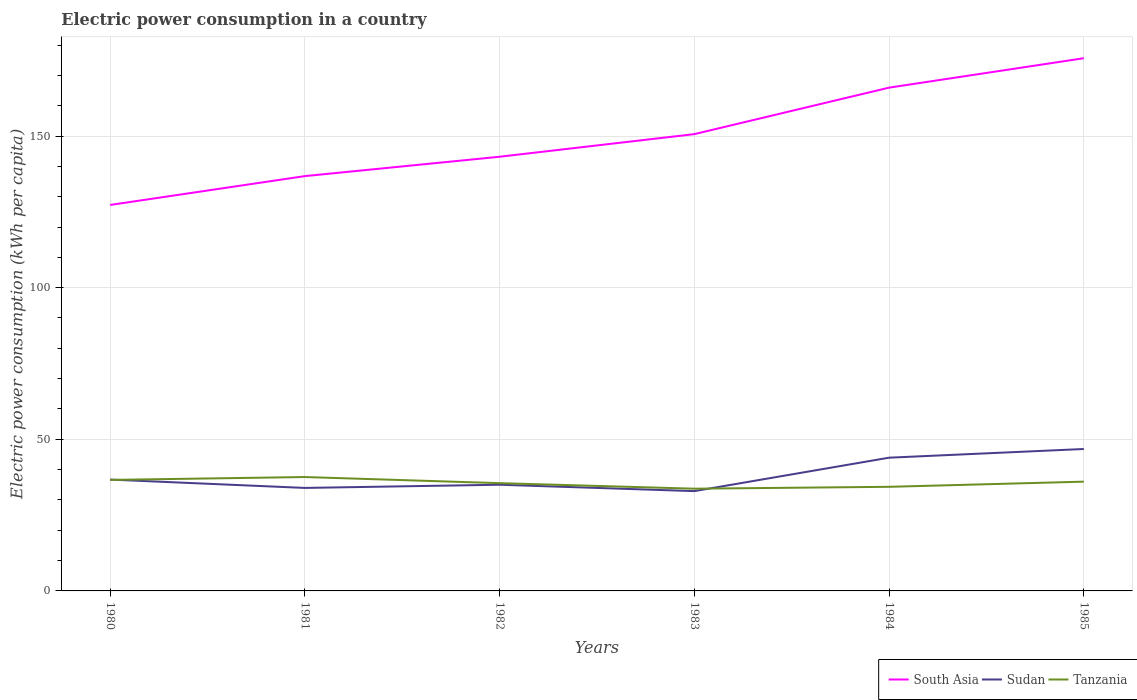How many different coloured lines are there?
Provide a short and direct response. 3. Across all years, what is the maximum electric power consumption in in Sudan?
Your response must be concise. 32.91. What is the total electric power consumption in in South Asia in the graph?
Ensure brevity in your answer.  -25.03. What is the difference between the highest and the second highest electric power consumption in in South Asia?
Ensure brevity in your answer.  48.39. What is the difference between the highest and the lowest electric power consumption in in South Asia?
Keep it short and to the point. 3. Is the electric power consumption in in Tanzania strictly greater than the electric power consumption in in South Asia over the years?
Provide a succinct answer. Yes. How many years are there in the graph?
Make the answer very short. 6. What is the difference between two consecutive major ticks on the Y-axis?
Ensure brevity in your answer.  50. Are the values on the major ticks of Y-axis written in scientific E-notation?
Your answer should be very brief. No. Does the graph contain grids?
Your answer should be very brief. Yes. How many legend labels are there?
Ensure brevity in your answer.  3. How are the legend labels stacked?
Ensure brevity in your answer.  Horizontal. What is the title of the graph?
Offer a terse response. Electric power consumption in a country. Does "Rwanda" appear as one of the legend labels in the graph?
Provide a short and direct response. No. What is the label or title of the X-axis?
Ensure brevity in your answer.  Years. What is the label or title of the Y-axis?
Ensure brevity in your answer.  Electric power consumption (kWh per capita). What is the Electric power consumption (kWh per capita) in South Asia in 1980?
Provide a succinct answer. 127.27. What is the Electric power consumption (kWh per capita) in Sudan in 1980?
Give a very brief answer. 36.72. What is the Electric power consumption (kWh per capita) in Tanzania in 1980?
Your answer should be very brief. 36.61. What is the Electric power consumption (kWh per capita) in South Asia in 1981?
Your answer should be compact. 136.78. What is the Electric power consumption (kWh per capita) of Sudan in 1981?
Make the answer very short. 33.96. What is the Electric power consumption (kWh per capita) of Tanzania in 1981?
Offer a very short reply. 37.55. What is the Electric power consumption (kWh per capita) of South Asia in 1982?
Give a very brief answer. 143.17. What is the Electric power consumption (kWh per capita) in Sudan in 1982?
Keep it short and to the point. 35.01. What is the Electric power consumption (kWh per capita) in Tanzania in 1982?
Your answer should be compact. 35.54. What is the Electric power consumption (kWh per capita) of South Asia in 1983?
Provide a short and direct response. 150.62. What is the Electric power consumption (kWh per capita) in Sudan in 1983?
Provide a short and direct response. 32.91. What is the Electric power consumption (kWh per capita) in Tanzania in 1983?
Give a very brief answer. 33.71. What is the Electric power consumption (kWh per capita) in South Asia in 1984?
Provide a short and direct response. 165.95. What is the Electric power consumption (kWh per capita) of Sudan in 1984?
Provide a succinct answer. 43.93. What is the Electric power consumption (kWh per capita) in Tanzania in 1984?
Keep it short and to the point. 34.33. What is the Electric power consumption (kWh per capita) of South Asia in 1985?
Give a very brief answer. 175.66. What is the Electric power consumption (kWh per capita) of Sudan in 1985?
Give a very brief answer. 46.8. What is the Electric power consumption (kWh per capita) of Tanzania in 1985?
Offer a terse response. 36.03. Across all years, what is the maximum Electric power consumption (kWh per capita) in South Asia?
Your response must be concise. 175.66. Across all years, what is the maximum Electric power consumption (kWh per capita) of Sudan?
Offer a very short reply. 46.8. Across all years, what is the maximum Electric power consumption (kWh per capita) of Tanzania?
Offer a terse response. 37.55. Across all years, what is the minimum Electric power consumption (kWh per capita) of South Asia?
Offer a terse response. 127.27. Across all years, what is the minimum Electric power consumption (kWh per capita) in Sudan?
Your answer should be compact. 32.91. Across all years, what is the minimum Electric power consumption (kWh per capita) of Tanzania?
Offer a terse response. 33.71. What is the total Electric power consumption (kWh per capita) of South Asia in the graph?
Give a very brief answer. 899.45. What is the total Electric power consumption (kWh per capita) in Sudan in the graph?
Give a very brief answer. 229.34. What is the total Electric power consumption (kWh per capita) in Tanzania in the graph?
Your answer should be compact. 213.77. What is the difference between the Electric power consumption (kWh per capita) of South Asia in 1980 and that in 1981?
Offer a terse response. -9.51. What is the difference between the Electric power consumption (kWh per capita) of Sudan in 1980 and that in 1981?
Provide a short and direct response. 2.75. What is the difference between the Electric power consumption (kWh per capita) in Tanzania in 1980 and that in 1981?
Offer a very short reply. -0.95. What is the difference between the Electric power consumption (kWh per capita) in South Asia in 1980 and that in 1982?
Your answer should be compact. -15.9. What is the difference between the Electric power consumption (kWh per capita) of Sudan in 1980 and that in 1982?
Offer a terse response. 1.7. What is the difference between the Electric power consumption (kWh per capita) in Tanzania in 1980 and that in 1982?
Offer a terse response. 1.07. What is the difference between the Electric power consumption (kWh per capita) in South Asia in 1980 and that in 1983?
Offer a terse response. -23.35. What is the difference between the Electric power consumption (kWh per capita) in Sudan in 1980 and that in 1983?
Keep it short and to the point. 3.81. What is the difference between the Electric power consumption (kWh per capita) of Tanzania in 1980 and that in 1983?
Keep it short and to the point. 2.9. What is the difference between the Electric power consumption (kWh per capita) in South Asia in 1980 and that in 1984?
Your response must be concise. -38.69. What is the difference between the Electric power consumption (kWh per capita) in Sudan in 1980 and that in 1984?
Your answer should be compact. -7.22. What is the difference between the Electric power consumption (kWh per capita) in Tanzania in 1980 and that in 1984?
Your answer should be compact. 2.28. What is the difference between the Electric power consumption (kWh per capita) in South Asia in 1980 and that in 1985?
Ensure brevity in your answer.  -48.39. What is the difference between the Electric power consumption (kWh per capita) of Sudan in 1980 and that in 1985?
Make the answer very short. -10.08. What is the difference between the Electric power consumption (kWh per capita) in Tanzania in 1980 and that in 1985?
Give a very brief answer. 0.58. What is the difference between the Electric power consumption (kWh per capita) in South Asia in 1981 and that in 1982?
Offer a very short reply. -6.39. What is the difference between the Electric power consumption (kWh per capita) in Sudan in 1981 and that in 1982?
Provide a short and direct response. -1.05. What is the difference between the Electric power consumption (kWh per capita) in Tanzania in 1981 and that in 1982?
Offer a terse response. 2.02. What is the difference between the Electric power consumption (kWh per capita) of South Asia in 1981 and that in 1983?
Make the answer very short. -13.84. What is the difference between the Electric power consumption (kWh per capita) of Sudan in 1981 and that in 1983?
Your response must be concise. 1.06. What is the difference between the Electric power consumption (kWh per capita) in Tanzania in 1981 and that in 1983?
Provide a succinct answer. 3.84. What is the difference between the Electric power consumption (kWh per capita) of South Asia in 1981 and that in 1984?
Offer a very short reply. -29.17. What is the difference between the Electric power consumption (kWh per capita) in Sudan in 1981 and that in 1984?
Your response must be concise. -9.97. What is the difference between the Electric power consumption (kWh per capita) in Tanzania in 1981 and that in 1984?
Your response must be concise. 3.22. What is the difference between the Electric power consumption (kWh per capita) in South Asia in 1981 and that in 1985?
Provide a short and direct response. -38.87. What is the difference between the Electric power consumption (kWh per capita) of Sudan in 1981 and that in 1985?
Give a very brief answer. -12.84. What is the difference between the Electric power consumption (kWh per capita) in Tanzania in 1981 and that in 1985?
Provide a succinct answer. 1.52. What is the difference between the Electric power consumption (kWh per capita) of South Asia in 1982 and that in 1983?
Offer a very short reply. -7.46. What is the difference between the Electric power consumption (kWh per capita) in Sudan in 1982 and that in 1983?
Provide a succinct answer. 2.11. What is the difference between the Electric power consumption (kWh per capita) in Tanzania in 1982 and that in 1983?
Keep it short and to the point. 1.83. What is the difference between the Electric power consumption (kWh per capita) of South Asia in 1982 and that in 1984?
Your answer should be very brief. -22.79. What is the difference between the Electric power consumption (kWh per capita) of Sudan in 1982 and that in 1984?
Your answer should be very brief. -8.92. What is the difference between the Electric power consumption (kWh per capita) in Tanzania in 1982 and that in 1984?
Your answer should be very brief. 1.21. What is the difference between the Electric power consumption (kWh per capita) of South Asia in 1982 and that in 1985?
Ensure brevity in your answer.  -32.49. What is the difference between the Electric power consumption (kWh per capita) in Sudan in 1982 and that in 1985?
Make the answer very short. -11.79. What is the difference between the Electric power consumption (kWh per capita) of Tanzania in 1982 and that in 1985?
Provide a short and direct response. -0.49. What is the difference between the Electric power consumption (kWh per capita) of South Asia in 1983 and that in 1984?
Provide a succinct answer. -15.33. What is the difference between the Electric power consumption (kWh per capita) in Sudan in 1983 and that in 1984?
Your answer should be very brief. -11.03. What is the difference between the Electric power consumption (kWh per capita) of Tanzania in 1983 and that in 1984?
Keep it short and to the point. -0.62. What is the difference between the Electric power consumption (kWh per capita) of South Asia in 1983 and that in 1985?
Offer a terse response. -25.03. What is the difference between the Electric power consumption (kWh per capita) of Sudan in 1983 and that in 1985?
Keep it short and to the point. -13.89. What is the difference between the Electric power consumption (kWh per capita) in Tanzania in 1983 and that in 1985?
Your answer should be compact. -2.32. What is the difference between the Electric power consumption (kWh per capita) in South Asia in 1984 and that in 1985?
Your response must be concise. -9.7. What is the difference between the Electric power consumption (kWh per capita) in Sudan in 1984 and that in 1985?
Provide a short and direct response. -2.87. What is the difference between the Electric power consumption (kWh per capita) of Tanzania in 1984 and that in 1985?
Give a very brief answer. -1.7. What is the difference between the Electric power consumption (kWh per capita) in South Asia in 1980 and the Electric power consumption (kWh per capita) in Sudan in 1981?
Ensure brevity in your answer.  93.3. What is the difference between the Electric power consumption (kWh per capita) in South Asia in 1980 and the Electric power consumption (kWh per capita) in Tanzania in 1981?
Give a very brief answer. 89.72. What is the difference between the Electric power consumption (kWh per capita) in Sudan in 1980 and the Electric power consumption (kWh per capita) in Tanzania in 1981?
Offer a very short reply. -0.84. What is the difference between the Electric power consumption (kWh per capita) in South Asia in 1980 and the Electric power consumption (kWh per capita) in Sudan in 1982?
Provide a succinct answer. 92.26. What is the difference between the Electric power consumption (kWh per capita) in South Asia in 1980 and the Electric power consumption (kWh per capita) in Tanzania in 1982?
Your response must be concise. 91.73. What is the difference between the Electric power consumption (kWh per capita) of Sudan in 1980 and the Electric power consumption (kWh per capita) of Tanzania in 1982?
Ensure brevity in your answer.  1.18. What is the difference between the Electric power consumption (kWh per capita) of South Asia in 1980 and the Electric power consumption (kWh per capita) of Sudan in 1983?
Offer a very short reply. 94.36. What is the difference between the Electric power consumption (kWh per capita) in South Asia in 1980 and the Electric power consumption (kWh per capita) in Tanzania in 1983?
Your answer should be compact. 93.56. What is the difference between the Electric power consumption (kWh per capita) in Sudan in 1980 and the Electric power consumption (kWh per capita) in Tanzania in 1983?
Your answer should be very brief. 3.01. What is the difference between the Electric power consumption (kWh per capita) of South Asia in 1980 and the Electric power consumption (kWh per capita) of Sudan in 1984?
Your response must be concise. 83.33. What is the difference between the Electric power consumption (kWh per capita) of South Asia in 1980 and the Electric power consumption (kWh per capita) of Tanzania in 1984?
Provide a short and direct response. 92.94. What is the difference between the Electric power consumption (kWh per capita) in Sudan in 1980 and the Electric power consumption (kWh per capita) in Tanzania in 1984?
Offer a terse response. 2.39. What is the difference between the Electric power consumption (kWh per capita) in South Asia in 1980 and the Electric power consumption (kWh per capita) in Sudan in 1985?
Ensure brevity in your answer.  80.47. What is the difference between the Electric power consumption (kWh per capita) of South Asia in 1980 and the Electric power consumption (kWh per capita) of Tanzania in 1985?
Ensure brevity in your answer.  91.24. What is the difference between the Electric power consumption (kWh per capita) of Sudan in 1980 and the Electric power consumption (kWh per capita) of Tanzania in 1985?
Ensure brevity in your answer.  0.69. What is the difference between the Electric power consumption (kWh per capita) in South Asia in 1981 and the Electric power consumption (kWh per capita) in Sudan in 1982?
Provide a succinct answer. 101.77. What is the difference between the Electric power consumption (kWh per capita) of South Asia in 1981 and the Electric power consumption (kWh per capita) of Tanzania in 1982?
Ensure brevity in your answer.  101.25. What is the difference between the Electric power consumption (kWh per capita) in Sudan in 1981 and the Electric power consumption (kWh per capita) in Tanzania in 1982?
Keep it short and to the point. -1.57. What is the difference between the Electric power consumption (kWh per capita) of South Asia in 1981 and the Electric power consumption (kWh per capita) of Sudan in 1983?
Your answer should be compact. 103.88. What is the difference between the Electric power consumption (kWh per capita) of South Asia in 1981 and the Electric power consumption (kWh per capita) of Tanzania in 1983?
Offer a terse response. 103.07. What is the difference between the Electric power consumption (kWh per capita) in Sudan in 1981 and the Electric power consumption (kWh per capita) in Tanzania in 1983?
Give a very brief answer. 0.26. What is the difference between the Electric power consumption (kWh per capita) in South Asia in 1981 and the Electric power consumption (kWh per capita) in Sudan in 1984?
Provide a short and direct response. 92.85. What is the difference between the Electric power consumption (kWh per capita) of South Asia in 1981 and the Electric power consumption (kWh per capita) of Tanzania in 1984?
Provide a succinct answer. 102.45. What is the difference between the Electric power consumption (kWh per capita) in Sudan in 1981 and the Electric power consumption (kWh per capita) in Tanzania in 1984?
Provide a succinct answer. -0.36. What is the difference between the Electric power consumption (kWh per capita) in South Asia in 1981 and the Electric power consumption (kWh per capita) in Sudan in 1985?
Your response must be concise. 89.98. What is the difference between the Electric power consumption (kWh per capita) of South Asia in 1981 and the Electric power consumption (kWh per capita) of Tanzania in 1985?
Give a very brief answer. 100.75. What is the difference between the Electric power consumption (kWh per capita) of Sudan in 1981 and the Electric power consumption (kWh per capita) of Tanzania in 1985?
Your answer should be very brief. -2.07. What is the difference between the Electric power consumption (kWh per capita) in South Asia in 1982 and the Electric power consumption (kWh per capita) in Sudan in 1983?
Your answer should be compact. 110.26. What is the difference between the Electric power consumption (kWh per capita) in South Asia in 1982 and the Electric power consumption (kWh per capita) in Tanzania in 1983?
Your response must be concise. 109.46. What is the difference between the Electric power consumption (kWh per capita) of Sudan in 1982 and the Electric power consumption (kWh per capita) of Tanzania in 1983?
Provide a short and direct response. 1.3. What is the difference between the Electric power consumption (kWh per capita) of South Asia in 1982 and the Electric power consumption (kWh per capita) of Sudan in 1984?
Ensure brevity in your answer.  99.23. What is the difference between the Electric power consumption (kWh per capita) in South Asia in 1982 and the Electric power consumption (kWh per capita) in Tanzania in 1984?
Provide a short and direct response. 108.84. What is the difference between the Electric power consumption (kWh per capita) in Sudan in 1982 and the Electric power consumption (kWh per capita) in Tanzania in 1984?
Provide a succinct answer. 0.69. What is the difference between the Electric power consumption (kWh per capita) in South Asia in 1982 and the Electric power consumption (kWh per capita) in Sudan in 1985?
Your answer should be compact. 96.37. What is the difference between the Electric power consumption (kWh per capita) in South Asia in 1982 and the Electric power consumption (kWh per capita) in Tanzania in 1985?
Your answer should be compact. 107.14. What is the difference between the Electric power consumption (kWh per capita) of Sudan in 1982 and the Electric power consumption (kWh per capita) of Tanzania in 1985?
Give a very brief answer. -1.02. What is the difference between the Electric power consumption (kWh per capita) of South Asia in 1983 and the Electric power consumption (kWh per capita) of Sudan in 1984?
Make the answer very short. 106.69. What is the difference between the Electric power consumption (kWh per capita) of South Asia in 1983 and the Electric power consumption (kWh per capita) of Tanzania in 1984?
Offer a terse response. 116.3. What is the difference between the Electric power consumption (kWh per capita) of Sudan in 1983 and the Electric power consumption (kWh per capita) of Tanzania in 1984?
Your answer should be very brief. -1.42. What is the difference between the Electric power consumption (kWh per capita) of South Asia in 1983 and the Electric power consumption (kWh per capita) of Sudan in 1985?
Make the answer very short. 103.82. What is the difference between the Electric power consumption (kWh per capita) of South Asia in 1983 and the Electric power consumption (kWh per capita) of Tanzania in 1985?
Your response must be concise. 114.59. What is the difference between the Electric power consumption (kWh per capita) of Sudan in 1983 and the Electric power consumption (kWh per capita) of Tanzania in 1985?
Your response must be concise. -3.12. What is the difference between the Electric power consumption (kWh per capita) in South Asia in 1984 and the Electric power consumption (kWh per capita) in Sudan in 1985?
Provide a short and direct response. 119.15. What is the difference between the Electric power consumption (kWh per capita) of South Asia in 1984 and the Electric power consumption (kWh per capita) of Tanzania in 1985?
Ensure brevity in your answer.  129.92. What is the difference between the Electric power consumption (kWh per capita) in Sudan in 1984 and the Electric power consumption (kWh per capita) in Tanzania in 1985?
Provide a succinct answer. 7.9. What is the average Electric power consumption (kWh per capita) in South Asia per year?
Ensure brevity in your answer.  149.91. What is the average Electric power consumption (kWh per capita) of Sudan per year?
Ensure brevity in your answer.  38.22. What is the average Electric power consumption (kWh per capita) of Tanzania per year?
Give a very brief answer. 35.63. In the year 1980, what is the difference between the Electric power consumption (kWh per capita) of South Asia and Electric power consumption (kWh per capita) of Sudan?
Keep it short and to the point. 90.55. In the year 1980, what is the difference between the Electric power consumption (kWh per capita) of South Asia and Electric power consumption (kWh per capita) of Tanzania?
Your answer should be compact. 90.66. In the year 1980, what is the difference between the Electric power consumption (kWh per capita) in Sudan and Electric power consumption (kWh per capita) in Tanzania?
Provide a succinct answer. 0.11. In the year 1981, what is the difference between the Electric power consumption (kWh per capita) of South Asia and Electric power consumption (kWh per capita) of Sudan?
Offer a very short reply. 102.82. In the year 1981, what is the difference between the Electric power consumption (kWh per capita) of South Asia and Electric power consumption (kWh per capita) of Tanzania?
Give a very brief answer. 99.23. In the year 1981, what is the difference between the Electric power consumption (kWh per capita) in Sudan and Electric power consumption (kWh per capita) in Tanzania?
Your response must be concise. -3.59. In the year 1982, what is the difference between the Electric power consumption (kWh per capita) in South Asia and Electric power consumption (kWh per capita) in Sudan?
Provide a short and direct response. 108.15. In the year 1982, what is the difference between the Electric power consumption (kWh per capita) of South Asia and Electric power consumption (kWh per capita) of Tanzania?
Your response must be concise. 107.63. In the year 1982, what is the difference between the Electric power consumption (kWh per capita) in Sudan and Electric power consumption (kWh per capita) in Tanzania?
Ensure brevity in your answer.  -0.52. In the year 1983, what is the difference between the Electric power consumption (kWh per capita) in South Asia and Electric power consumption (kWh per capita) in Sudan?
Offer a very short reply. 117.72. In the year 1983, what is the difference between the Electric power consumption (kWh per capita) of South Asia and Electric power consumption (kWh per capita) of Tanzania?
Keep it short and to the point. 116.91. In the year 1983, what is the difference between the Electric power consumption (kWh per capita) of Sudan and Electric power consumption (kWh per capita) of Tanzania?
Make the answer very short. -0.8. In the year 1984, what is the difference between the Electric power consumption (kWh per capita) in South Asia and Electric power consumption (kWh per capita) in Sudan?
Give a very brief answer. 122.02. In the year 1984, what is the difference between the Electric power consumption (kWh per capita) in South Asia and Electric power consumption (kWh per capita) in Tanzania?
Your answer should be very brief. 131.63. In the year 1984, what is the difference between the Electric power consumption (kWh per capita) in Sudan and Electric power consumption (kWh per capita) in Tanzania?
Your answer should be very brief. 9.61. In the year 1985, what is the difference between the Electric power consumption (kWh per capita) of South Asia and Electric power consumption (kWh per capita) of Sudan?
Ensure brevity in your answer.  128.86. In the year 1985, what is the difference between the Electric power consumption (kWh per capita) of South Asia and Electric power consumption (kWh per capita) of Tanzania?
Offer a very short reply. 139.62. In the year 1985, what is the difference between the Electric power consumption (kWh per capita) of Sudan and Electric power consumption (kWh per capita) of Tanzania?
Offer a terse response. 10.77. What is the ratio of the Electric power consumption (kWh per capita) of South Asia in 1980 to that in 1981?
Provide a succinct answer. 0.93. What is the ratio of the Electric power consumption (kWh per capita) in Sudan in 1980 to that in 1981?
Give a very brief answer. 1.08. What is the ratio of the Electric power consumption (kWh per capita) in Tanzania in 1980 to that in 1981?
Give a very brief answer. 0.97. What is the ratio of the Electric power consumption (kWh per capita) in South Asia in 1980 to that in 1982?
Offer a terse response. 0.89. What is the ratio of the Electric power consumption (kWh per capita) in Sudan in 1980 to that in 1982?
Offer a terse response. 1.05. What is the ratio of the Electric power consumption (kWh per capita) of Tanzania in 1980 to that in 1982?
Your answer should be very brief. 1.03. What is the ratio of the Electric power consumption (kWh per capita) in South Asia in 1980 to that in 1983?
Keep it short and to the point. 0.84. What is the ratio of the Electric power consumption (kWh per capita) in Sudan in 1980 to that in 1983?
Provide a short and direct response. 1.12. What is the ratio of the Electric power consumption (kWh per capita) of Tanzania in 1980 to that in 1983?
Provide a short and direct response. 1.09. What is the ratio of the Electric power consumption (kWh per capita) in South Asia in 1980 to that in 1984?
Your response must be concise. 0.77. What is the ratio of the Electric power consumption (kWh per capita) of Sudan in 1980 to that in 1984?
Make the answer very short. 0.84. What is the ratio of the Electric power consumption (kWh per capita) in Tanzania in 1980 to that in 1984?
Provide a succinct answer. 1.07. What is the ratio of the Electric power consumption (kWh per capita) of South Asia in 1980 to that in 1985?
Ensure brevity in your answer.  0.72. What is the ratio of the Electric power consumption (kWh per capita) in Sudan in 1980 to that in 1985?
Your answer should be very brief. 0.78. What is the ratio of the Electric power consumption (kWh per capita) of Tanzania in 1980 to that in 1985?
Your answer should be compact. 1.02. What is the ratio of the Electric power consumption (kWh per capita) in South Asia in 1981 to that in 1982?
Provide a short and direct response. 0.96. What is the ratio of the Electric power consumption (kWh per capita) of Tanzania in 1981 to that in 1982?
Keep it short and to the point. 1.06. What is the ratio of the Electric power consumption (kWh per capita) of South Asia in 1981 to that in 1983?
Keep it short and to the point. 0.91. What is the ratio of the Electric power consumption (kWh per capita) in Sudan in 1981 to that in 1983?
Provide a succinct answer. 1.03. What is the ratio of the Electric power consumption (kWh per capita) of Tanzania in 1981 to that in 1983?
Offer a very short reply. 1.11. What is the ratio of the Electric power consumption (kWh per capita) of South Asia in 1981 to that in 1984?
Keep it short and to the point. 0.82. What is the ratio of the Electric power consumption (kWh per capita) of Sudan in 1981 to that in 1984?
Offer a very short reply. 0.77. What is the ratio of the Electric power consumption (kWh per capita) of Tanzania in 1981 to that in 1984?
Ensure brevity in your answer.  1.09. What is the ratio of the Electric power consumption (kWh per capita) in South Asia in 1981 to that in 1985?
Provide a short and direct response. 0.78. What is the ratio of the Electric power consumption (kWh per capita) of Sudan in 1981 to that in 1985?
Offer a terse response. 0.73. What is the ratio of the Electric power consumption (kWh per capita) in Tanzania in 1981 to that in 1985?
Keep it short and to the point. 1.04. What is the ratio of the Electric power consumption (kWh per capita) in South Asia in 1982 to that in 1983?
Provide a short and direct response. 0.95. What is the ratio of the Electric power consumption (kWh per capita) in Sudan in 1982 to that in 1983?
Your answer should be compact. 1.06. What is the ratio of the Electric power consumption (kWh per capita) of Tanzania in 1982 to that in 1983?
Make the answer very short. 1.05. What is the ratio of the Electric power consumption (kWh per capita) in South Asia in 1982 to that in 1984?
Provide a succinct answer. 0.86. What is the ratio of the Electric power consumption (kWh per capita) in Sudan in 1982 to that in 1984?
Give a very brief answer. 0.8. What is the ratio of the Electric power consumption (kWh per capita) in Tanzania in 1982 to that in 1984?
Offer a terse response. 1.04. What is the ratio of the Electric power consumption (kWh per capita) in South Asia in 1982 to that in 1985?
Offer a terse response. 0.81. What is the ratio of the Electric power consumption (kWh per capita) of Sudan in 1982 to that in 1985?
Provide a short and direct response. 0.75. What is the ratio of the Electric power consumption (kWh per capita) of Tanzania in 1982 to that in 1985?
Your response must be concise. 0.99. What is the ratio of the Electric power consumption (kWh per capita) of South Asia in 1983 to that in 1984?
Your response must be concise. 0.91. What is the ratio of the Electric power consumption (kWh per capita) of Sudan in 1983 to that in 1984?
Ensure brevity in your answer.  0.75. What is the ratio of the Electric power consumption (kWh per capita) in South Asia in 1983 to that in 1985?
Make the answer very short. 0.86. What is the ratio of the Electric power consumption (kWh per capita) in Sudan in 1983 to that in 1985?
Offer a very short reply. 0.7. What is the ratio of the Electric power consumption (kWh per capita) of Tanzania in 1983 to that in 1985?
Your answer should be very brief. 0.94. What is the ratio of the Electric power consumption (kWh per capita) in South Asia in 1984 to that in 1985?
Make the answer very short. 0.94. What is the ratio of the Electric power consumption (kWh per capita) in Sudan in 1984 to that in 1985?
Make the answer very short. 0.94. What is the ratio of the Electric power consumption (kWh per capita) in Tanzania in 1984 to that in 1985?
Keep it short and to the point. 0.95. What is the difference between the highest and the second highest Electric power consumption (kWh per capita) in South Asia?
Ensure brevity in your answer.  9.7. What is the difference between the highest and the second highest Electric power consumption (kWh per capita) of Sudan?
Ensure brevity in your answer.  2.87. What is the difference between the highest and the second highest Electric power consumption (kWh per capita) in Tanzania?
Ensure brevity in your answer.  0.95. What is the difference between the highest and the lowest Electric power consumption (kWh per capita) of South Asia?
Keep it short and to the point. 48.39. What is the difference between the highest and the lowest Electric power consumption (kWh per capita) in Sudan?
Your answer should be compact. 13.89. What is the difference between the highest and the lowest Electric power consumption (kWh per capita) in Tanzania?
Provide a succinct answer. 3.84. 